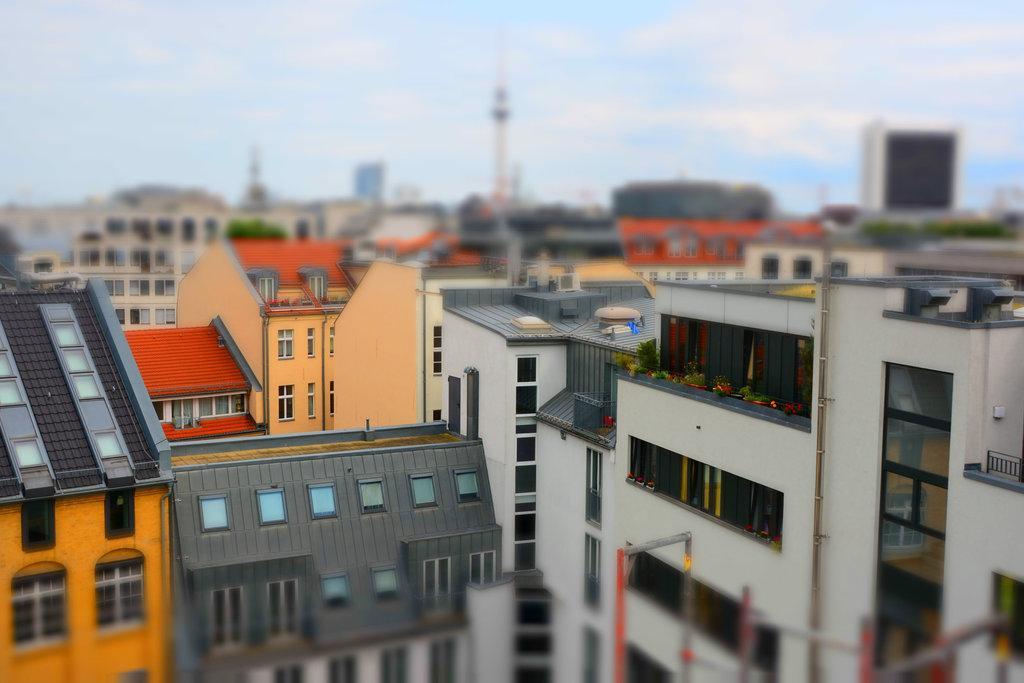In one or two sentences, can you explain what this image depicts? In the picture I can see the surrounding of the image is blurred and the center of the image is clear where I can see buildings and in the background, I can see the sky with clouds. 